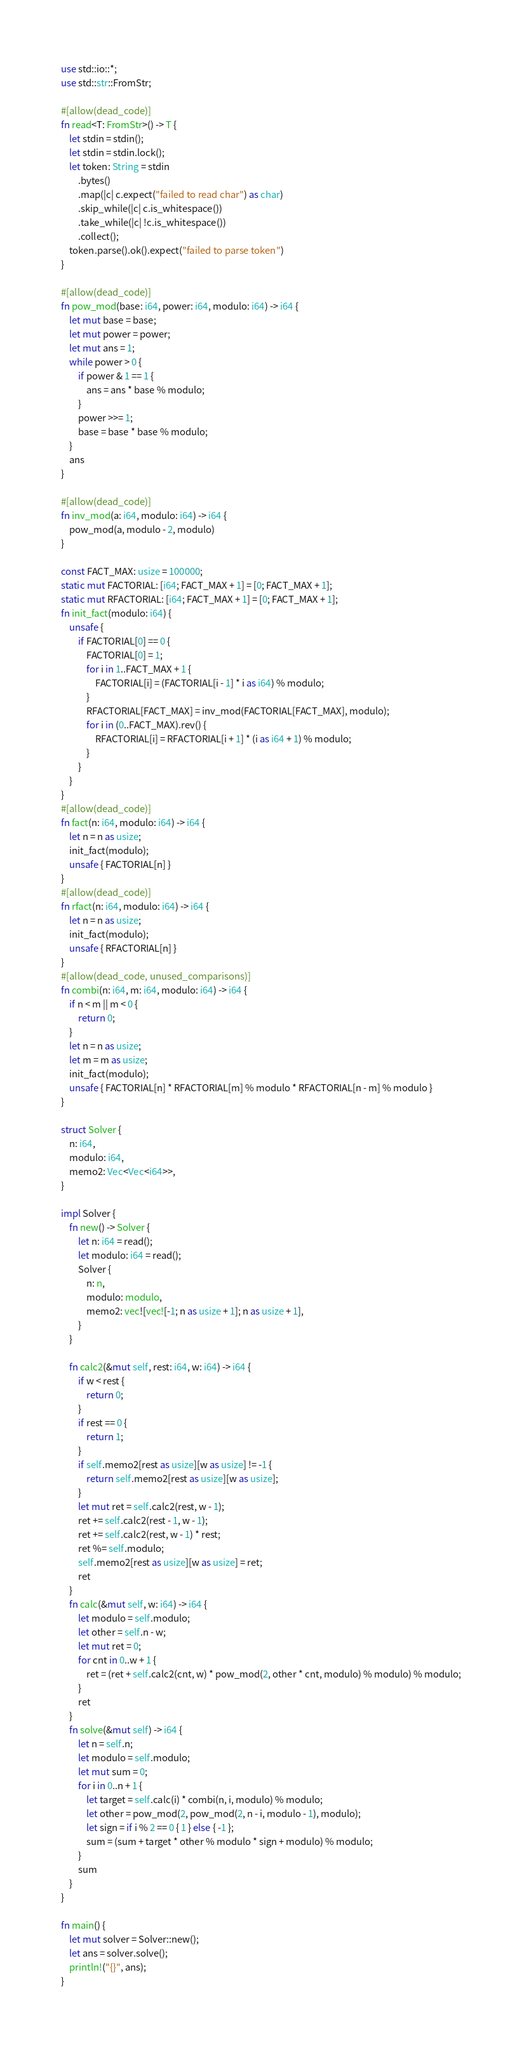<code> <loc_0><loc_0><loc_500><loc_500><_Rust_>use std::io::*;
use std::str::FromStr;

#[allow(dead_code)]
fn read<T: FromStr>() -> T {
    let stdin = stdin();
    let stdin = stdin.lock();
    let token: String = stdin
        .bytes()
        .map(|c| c.expect("failed to read char") as char)
        .skip_while(|c| c.is_whitespace())
        .take_while(|c| !c.is_whitespace())
        .collect();
    token.parse().ok().expect("failed to parse token")
}

#[allow(dead_code)]
fn pow_mod(base: i64, power: i64, modulo: i64) -> i64 {
    let mut base = base;
    let mut power = power;
    let mut ans = 1;
    while power > 0 {
        if power & 1 == 1 {
            ans = ans * base % modulo;
        }
        power >>= 1;
        base = base * base % modulo;
    }
    ans
}

#[allow(dead_code)]
fn inv_mod(a: i64, modulo: i64) -> i64 {
    pow_mod(a, modulo - 2, modulo)
}

const FACT_MAX: usize = 100000;
static mut FACTORIAL: [i64; FACT_MAX + 1] = [0; FACT_MAX + 1];
static mut RFACTORIAL: [i64; FACT_MAX + 1] = [0; FACT_MAX + 1];
fn init_fact(modulo: i64) {
    unsafe {
        if FACTORIAL[0] == 0 {
            FACTORIAL[0] = 1;
            for i in 1..FACT_MAX + 1 {
                FACTORIAL[i] = (FACTORIAL[i - 1] * i as i64) % modulo;
            }
            RFACTORIAL[FACT_MAX] = inv_mod(FACTORIAL[FACT_MAX], modulo);
            for i in (0..FACT_MAX).rev() {
                RFACTORIAL[i] = RFACTORIAL[i + 1] * (i as i64 + 1) % modulo;
            }
        }
    }
}
#[allow(dead_code)]
fn fact(n: i64, modulo: i64) -> i64 {
    let n = n as usize;
    init_fact(modulo);
    unsafe { FACTORIAL[n] }
}
#[allow(dead_code)]
fn rfact(n: i64, modulo: i64) -> i64 {
    let n = n as usize;
    init_fact(modulo);
    unsafe { RFACTORIAL[n] }
}
#[allow(dead_code, unused_comparisons)]
fn combi(n: i64, m: i64, modulo: i64) -> i64 {
    if n < m || m < 0 {
        return 0;
    }
    let n = n as usize;
    let m = m as usize;
    init_fact(modulo);
    unsafe { FACTORIAL[n] * RFACTORIAL[m] % modulo * RFACTORIAL[n - m] % modulo }
}

struct Solver {
    n: i64,
    modulo: i64,
    memo2: Vec<Vec<i64>>,
}

impl Solver {
    fn new() -> Solver {
        let n: i64 = read();
        let modulo: i64 = read();
        Solver {
            n: n,
            modulo: modulo,
            memo2: vec![vec![-1; n as usize + 1]; n as usize + 1],
        }
    }

    fn calc2(&mut self, rest: i64, w: i64) -> i64 {
        if w < rest {
            return 0;
        }
        if rest == 0 {
            return 1;
        }
        if self.memo2[rest as usize][w as usize] != -1 {
            return self.memo2[rest as usize][w as usize];
        }
        let mut ret = self.calc2(rest, w - 1);
        ret += self.calc2(rest - 1, w - 1);
        ret += self.calc2(rest, w - 1) * rest;
        ret %= self.modulo;
        self.memo2[rest as usize][w as usize] = ret;
        ret
    }
    fn calc(&mut self, w: i64) -> i64 {
        let modulo = self.modulo;
        let other = self.n - w;
        let mut ret = 0;
        for cnt in 0..w + 1 {
            ret = (ret + self.calc2(cnt, w) * pow_mod(2, other * cnt, modulo) % modulo) % modulo;
        }
        ret
    }
    fn solve(&mut self) -> i64 {
        let n = self.n;
        let modulo = self.modulo;
        let mut sum = 0;
        for i in 0..n + 1 {
            let target = self.calc(i) * combi(n, i, modulo) % modulo;
            let other = pow_mod(2, pow_mod(2, n - i, modulo - 1), modulo);
            let sign = if i % 2 == 0 { 1 } else { -1 };
            sum = (sum + target * other % modulo * sign + modulo) % modulo;
        }
        sum
    }
}

fn main() {
    let mut solver = Solver::new();
    let ans = solver.solve();
    println!("{}", ans);
}
</code> 